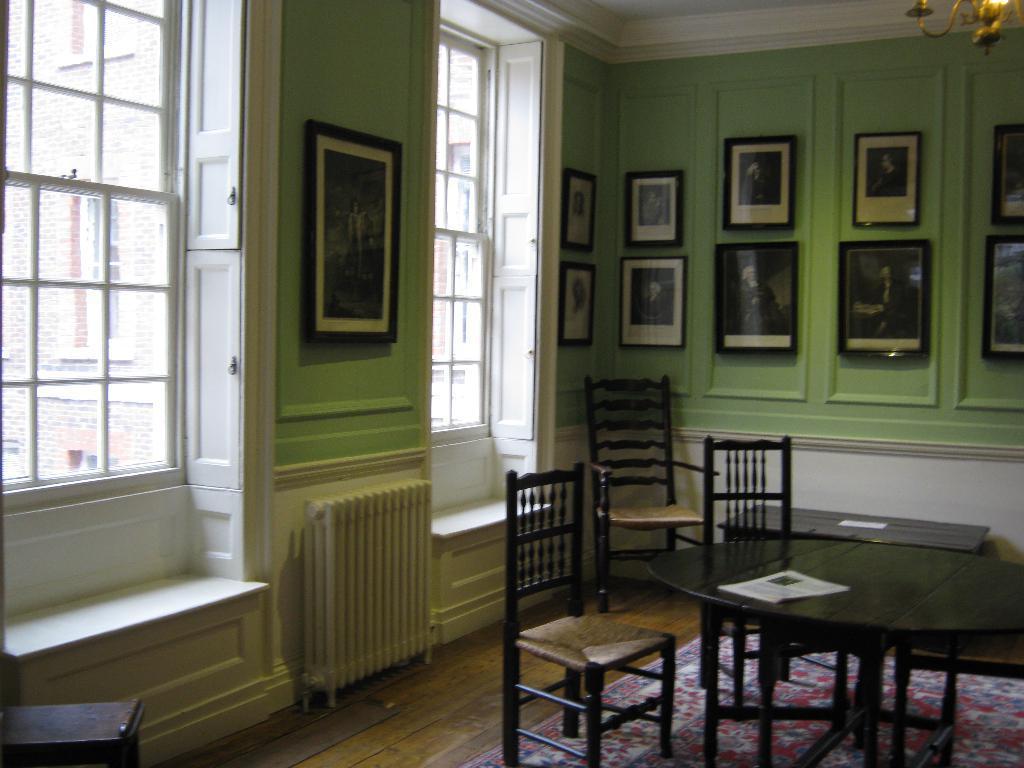In one or two sentences, can you explain what this image depicts? In this picture I can see chairs, tables, papers, a chandelier, there are frames attached to the wall, there are windows, and in the background it is looking like a building. 